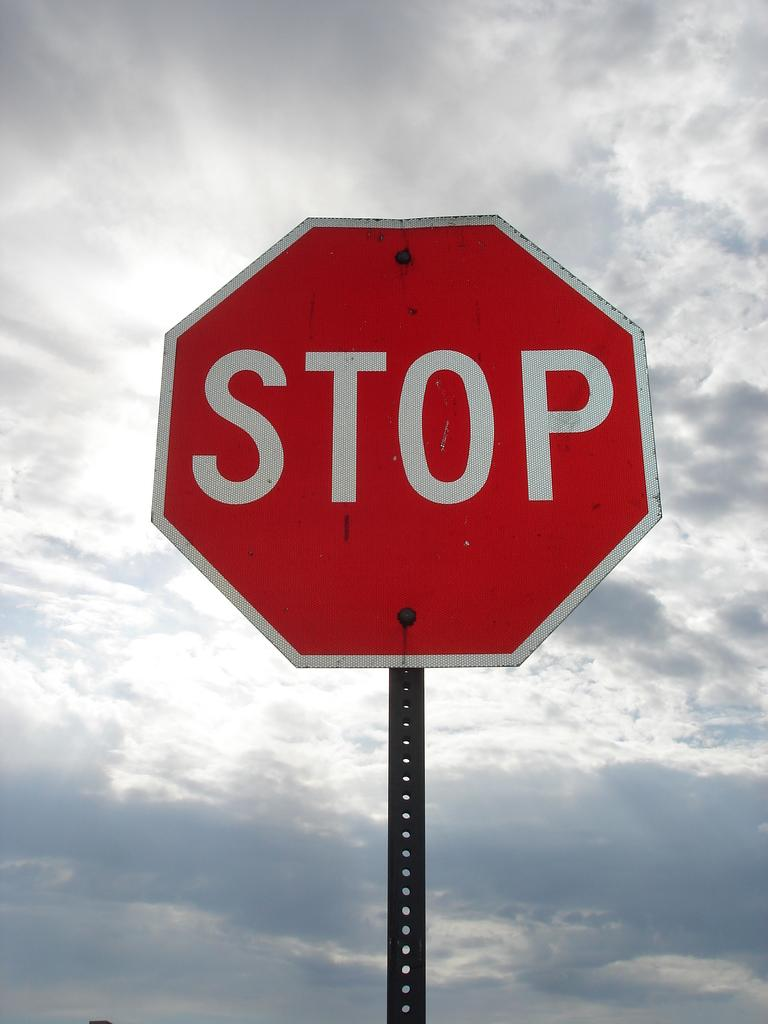<image>
Offer a succinct explanation of the picture presented. a stop sign that has the clouds above the land 